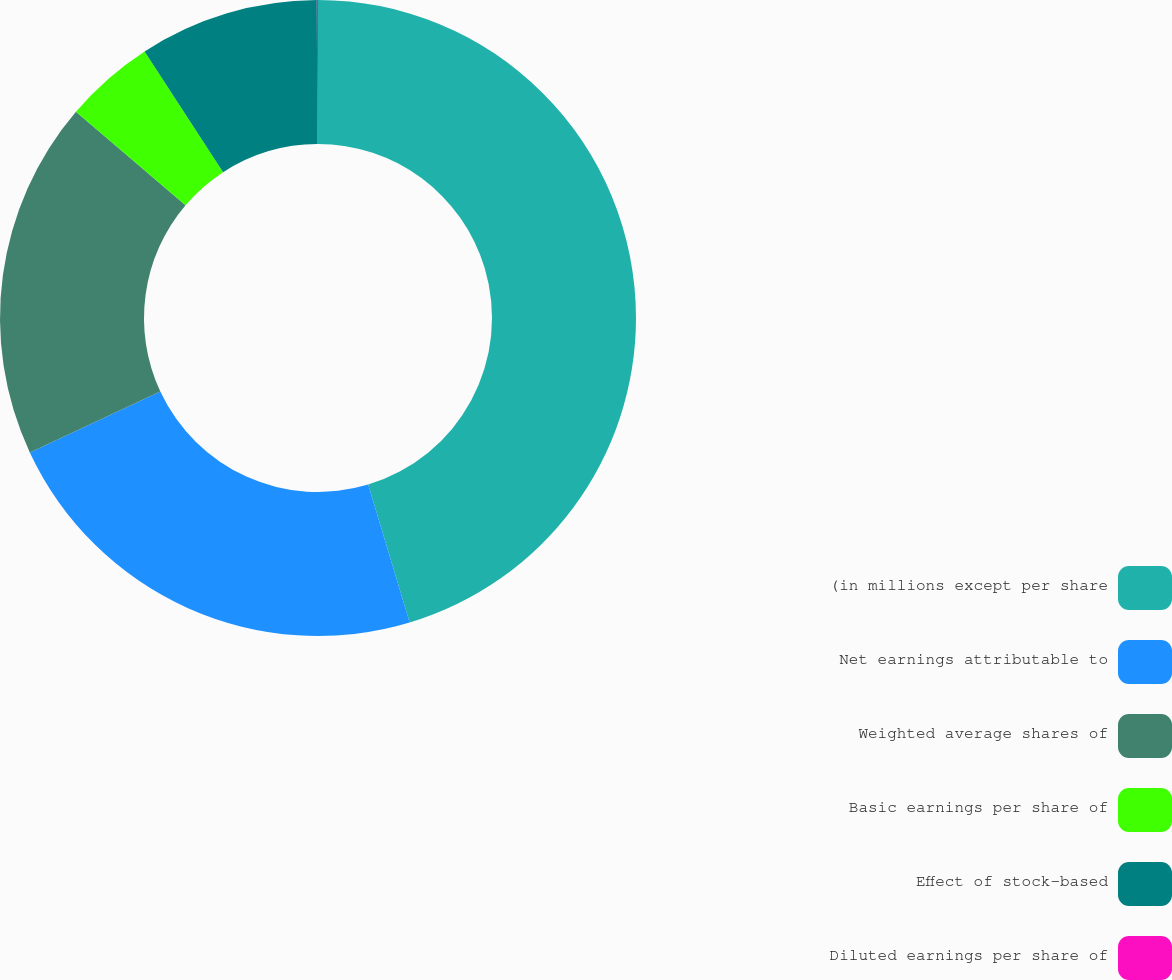<chart> <loc_0><loc_0><loc_500><loc_500><pie_chart><fcel>(in millions except per share<fcel>Net earnings attributable to<fcel>Weighted average shares of<fcel>Basic earnings per share of<fcel>Effect of stock-based<fcel>Diluted earnings per share of<nl><fcel>45.35%<fcel>22.71%<fcel>18.18%<fcel>4.59%<fcel>9.12%<fcel>0.06%<nl></chart> 